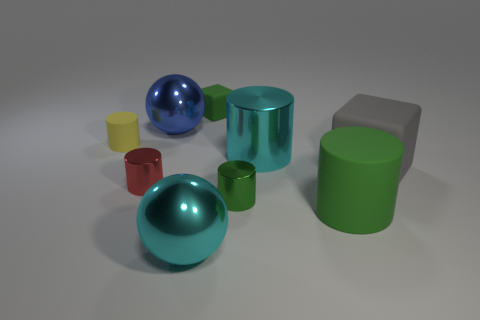Subtract all cyan cylinders. How many cylinders are left? 4 Subtract all large matte cylinders. How many cylinders are left? 4 Subtract all blue cylinders. Subtract all blue cubes. How many cylinders are left? 5 Add 1 cyan cylinders. How many objects exist? 10 Subtract all cylinders. How many objects are left? 4 Add 9 yellow rubber spheres. How many yellow rubber spheres exist? 9 Subtract 0 brown blocks. How many objects are left? 9 Subtract all big green objects. Subtract all gray blocks. How many objects are left? 7 Add 1 yellow objects. How many yellow objects are left? 2 